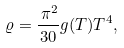<formula> <loc_0><loc_0><loc_500><loc_500>\varrho = \frac { \, \pi ^ { 2 } } { 3 0 } g ( T ) T ^ { 4 } ,</formula> 